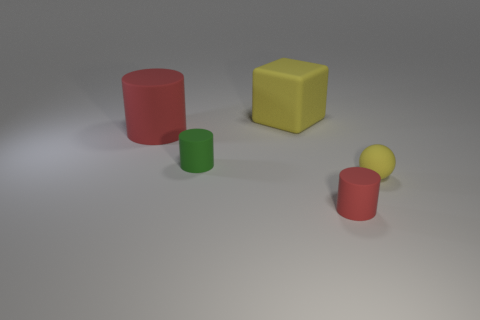How many cubes are either red matte objects or large red objects?
Your answer should be compact. 0. There is a large yellow thing; what shape is it?
Give a very brief answer. Cube. Are there any red rubber objects to the left of the cube?
Your answer should be compact. Yes. Is the material of the big cylinder the same as the big thing right of the green rubber cylinder?
Offer a terse response. Yes. There is a red object to the left of the small green rubber thing; is it the same shape as the large yellow rubber thing?
Your response must be concise. No. What number of yellow objects have the same material as the tiny red thing?
Your answer should be very brief. 2. How many things are red things that are left of the tiny green cylinder or small gray matte blocks?
Keep it short and to the point. 1. The yellow rubber block is what size?
Your response must be concise. Large. What material is the yellow thing to the left of the tiny cylinder to the right of the green matte thing?
Your response must be concise. Rubber. Does the red rubber object that is left of the green cylinder have the same size as the tiny yellow rubber object?
Keep it short and to the point. No. 